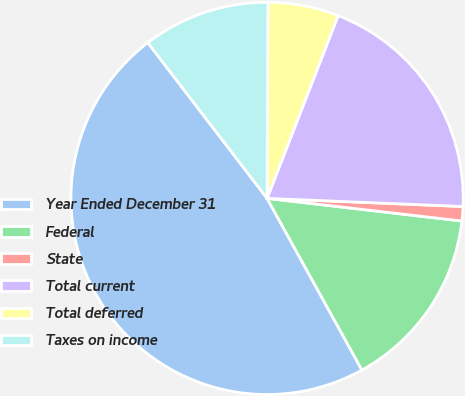Convert chart. <chart><loc_0><loc_0><loc_500><loc_500><pie_chart><fcel>Year Ended December 31<fcel>Federal<fcel>State<fcel>Total current<fcel>Total deferred<fcel>Taxes on income<nl><fcel>47.63%<fcel>15.12%<fcel>1.18%<fcel>19.76%<fcel>5.83%<fcel>10.47%<nl></chart> 